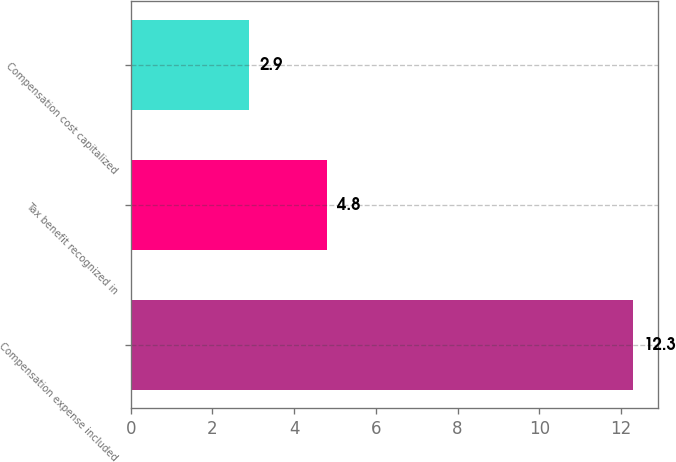Convert chart to OTSL. <chart><loc_0><loc_0><loc_500><loc_500><bar_chart><fcel>Compensation expense included<fcel>Tax benefit recognized in<fcel>Compensation cost capitalized<nl><fcel>12.3<fcel>4.8<fcel>2.9<nl></chart> 